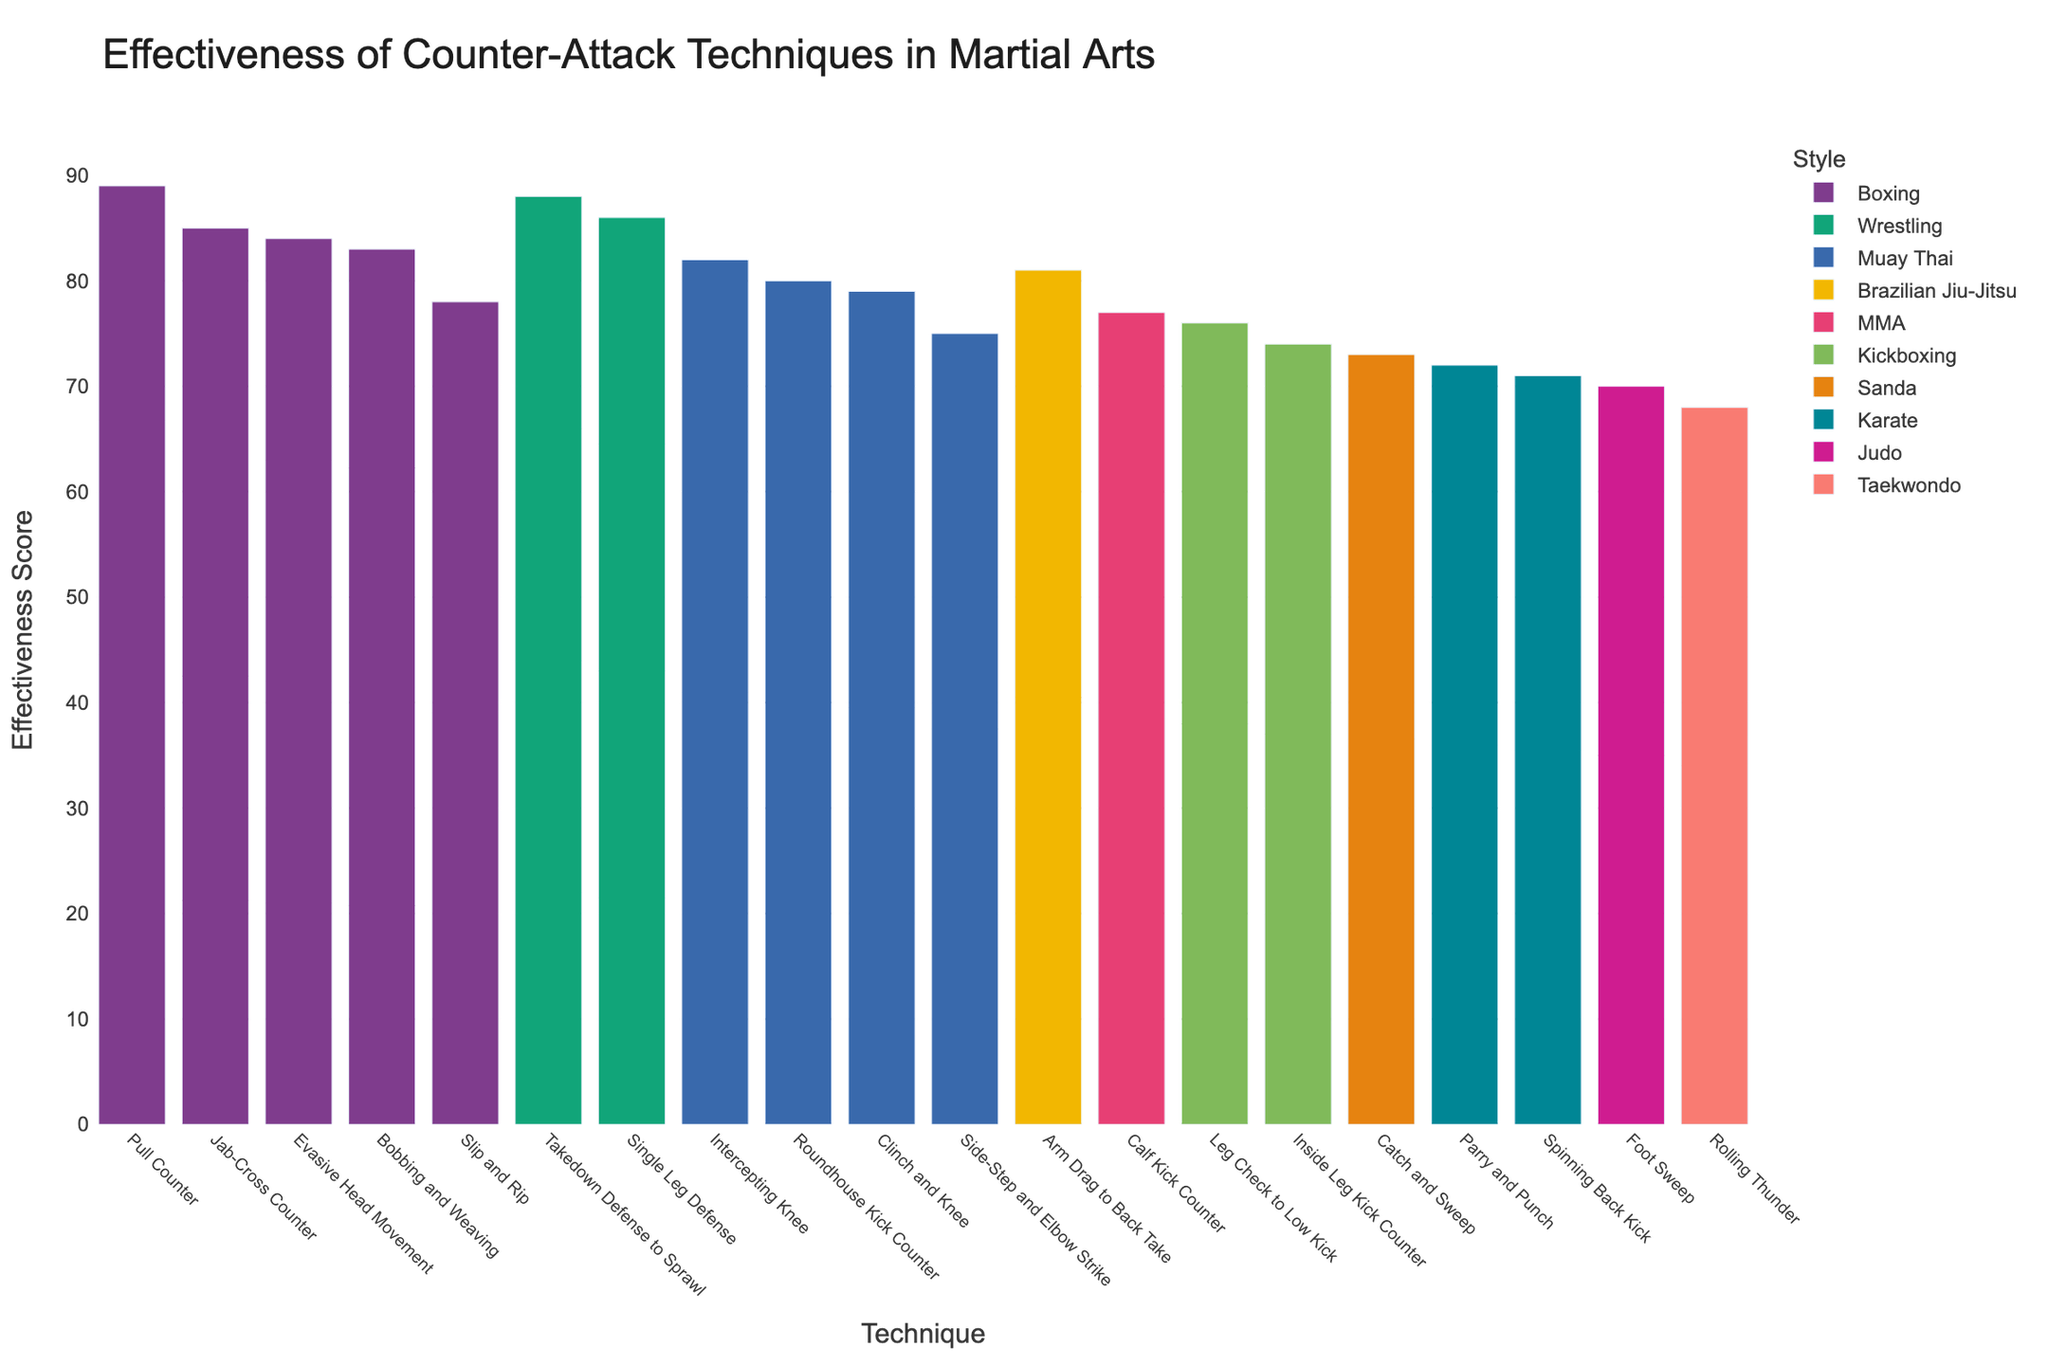What's the most effective counter-attack technique? Identify the bar with the highest effectiveness score, which is labeled on the x-axis
Answer: Pull Counter What is the effectiveness score difference between the Pull Counter (Boxing) and the Roundhouse Kick Counter (Muay Thai)? Locate the effectiveness scores of Pull Counter (89) and Roundhouse Kick Counter (80). Subtract the latter from the former: 89 - 80
Answer: 9 Which martial art style has the highest average effectiveness score for its techniques? Calculate the average effectiveness score for each style: Boxing (85 + 78 + 89 + 84 + 83)/5 = 83.8, Karate (72 + 71)/2 = 71.5, Muay Thai (80 + 75 + 82 + 79)/4 = 79, etc. Identify the style with the highest average
Answer: Boxing Are there more techniques from Boxing or Muay Thai in the chart? Count the number of techniques for each style: Boxing (5), Muay Thai (4)
Answer: Boxing Which technique has an effectiveness score closest to the average of all the techniques? Calculate the average effectiveness score of all techniques: (85 + 78 + 72 + 80 + 88 + 70 + 75 + 82 + 76 + 89 + 68 + 73 + 84 + 79 + 71 + 86 + 83 + 77 + 81 + 74)/20 = 78.55. Find the technique with the closest score
Answer: Leg Check to Low Kick Which is more effective: the most effective technique in Wrestling or the least effective technique in Kickboxing? Find the effectiveness score of the most effective Wrestling technique (Takedown Defense to Sprawl: 88) and the least effective Kickboxing technique (Inside Leg Kick Counter: 74). Compare the two scores
Answer: Takedown Defense to Sprawl How many techniques have an effectiveness score above 80? Count the number of bars with heights representing scores above 80
Answer: 7 What is the combined effectiveness score of all the Judo and Sanda techniques? Sum the effectiveness scores of Judo (Foot Sweep: 70) and Sanda (Catch and Sweep: 73): 70 + 73
Answer: 143 Does the most effective technique in Karate outperform the least effective technique in Wrestling? Compare the scores of the most effective Karate technique (Parry and Punch: 72) and the least effective Wrestling technique (Single Leg Defense: 86). Check if the former is greater
Answer: No 